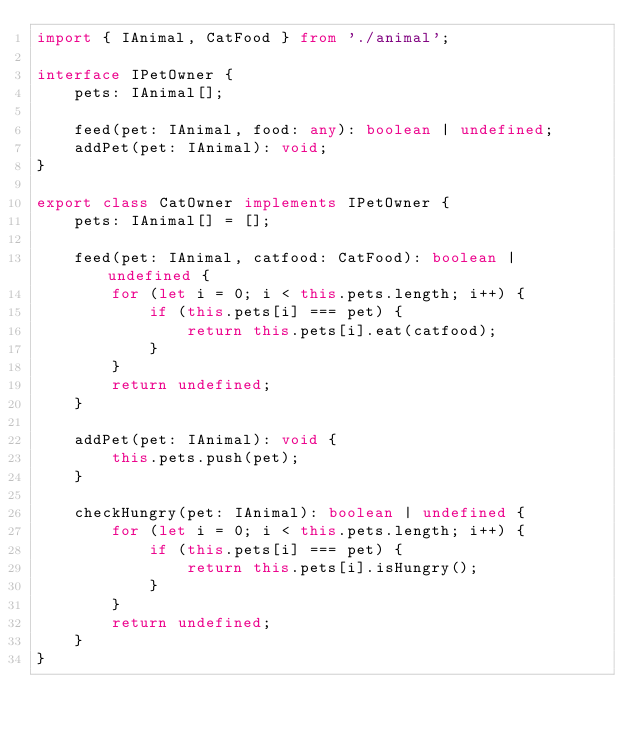<code> <loc_0><loc_0><loc_500><loc_500><_TypeScript_>import { IAnimal, CatFood } from './animal';

interface IPetOwner {
    pets: IAnimal[];

    feed(pet: IAnimal, food: any): boolean | undefined;
    addPet(pet: IAnimal): void;
}

export class CatOwner implements IPetOwner {
    pets: IAnimal[] = [];

    feed(pet: IAnimal, catfood: CatFood): boolean | undefined {
        for (let i = 0; i < this.pets.length; i++) {
            if (this.pets[i] === pet) {
                return this.pets[i].eat(catfood);
            }
        }
        return undefined;
    }

    addPet(pet: IAnimal): void {
        this.pets.push(pet);
    }

    checkHungry(pet: IAnimal): boolean | undefined {
        for (let i = 0; i < this.pets.length; i++) {
            if (this.pets[i] === pet) {
                return this.pets[i].isHungry();
            }
        }
        return undefined;
    }
}
</code> 